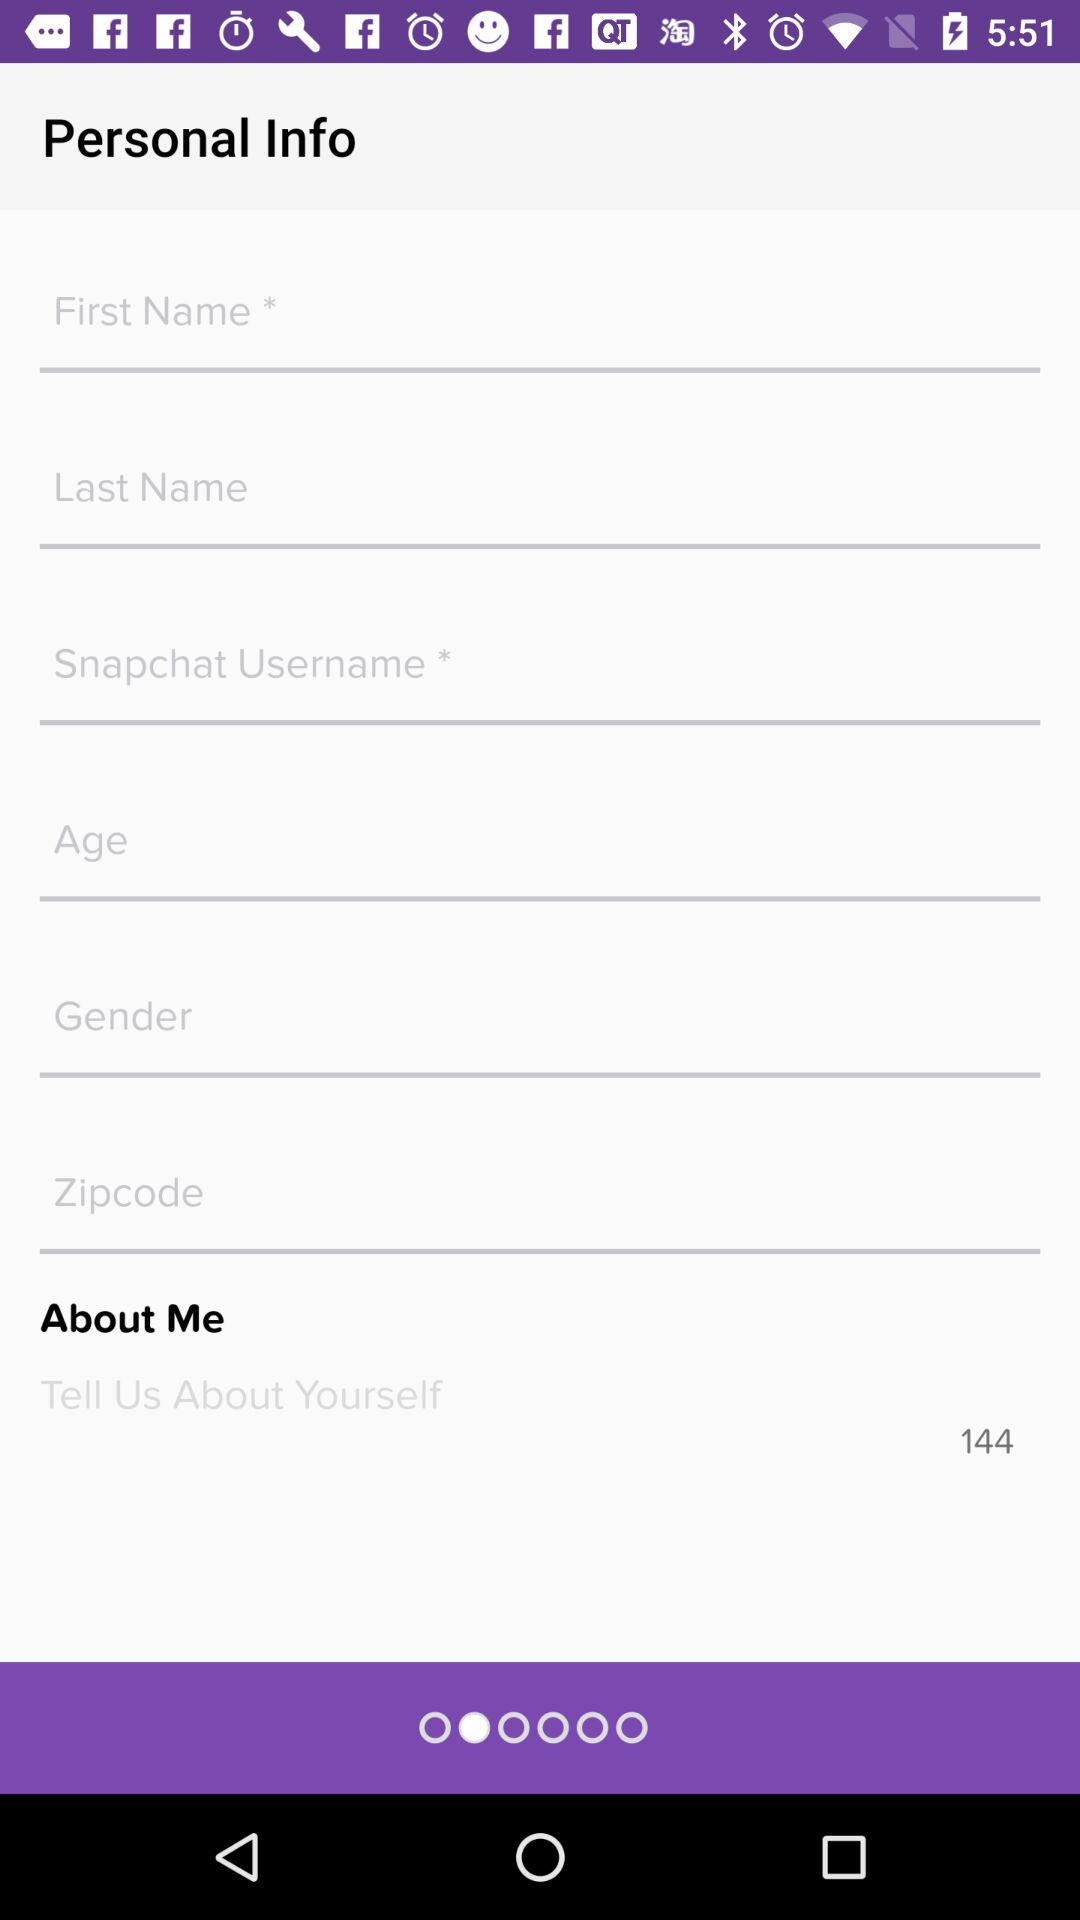What is the maximum number of characters that can be used for the description? The maximum number of characters that can be used for the description is 144. 